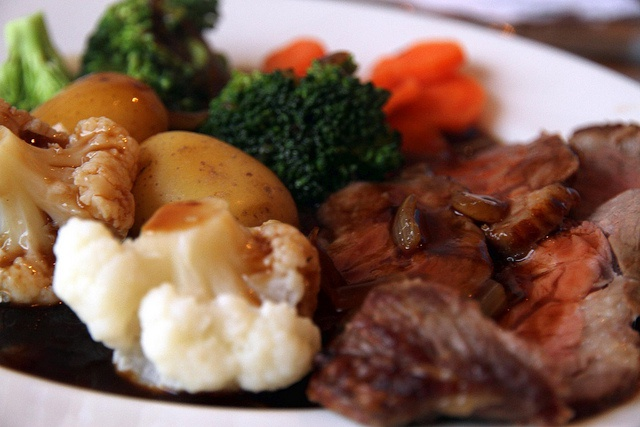Describe the objects in this image and their specific colors. I can see broccoli in darkgray, black, darkgreen, and olive tones, carrot in darkgray, brown, maroon, and red tones, carrot in darkgray, red, black, and brown tones, and carrot in darkgray, red, brown, and lightpink tones in this image. 